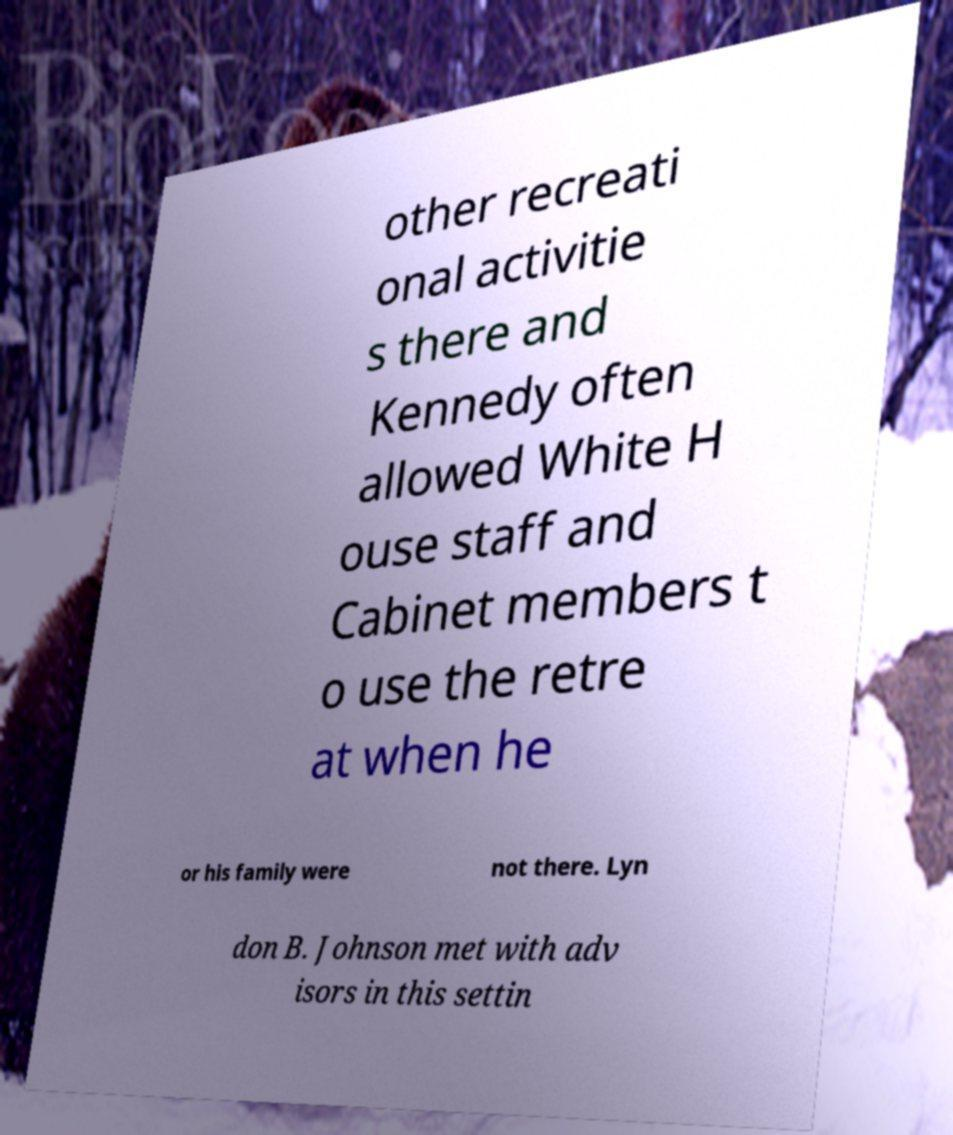Please identify and transcribe the text found in this image. other recreati onal activitie s there and Kennedy often allowed White H ouse staff and Cabinet members t o use the retre at when he or his family were not there. Lyn don B. Johnson met with adv isors in this settin 